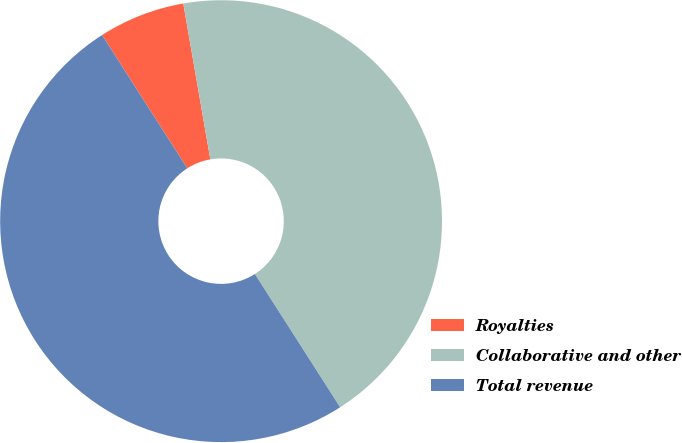Convert chart. <chart><loc_0><loc_0><loc_500><loc_500><pie_chart><fcel>Royalties<fcel>Collaborative and other<fcel>Total revenue<nl><fcel>6.32%<fcel>43.68%<fcel>50.0%<nl></chart> 